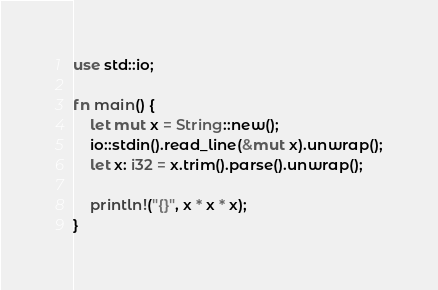Convert code to text. <code><loc_0><loc_0><loc_500><loc_500><_Rust_>use std::io;

fn main() {
    let mut x = String::new();
    io::stdin().read_line(&mut x).unwrap();
    let x: i32 = x.trim().parse().unwrap();

    println!("{}", x * x * x);
}


</code> 